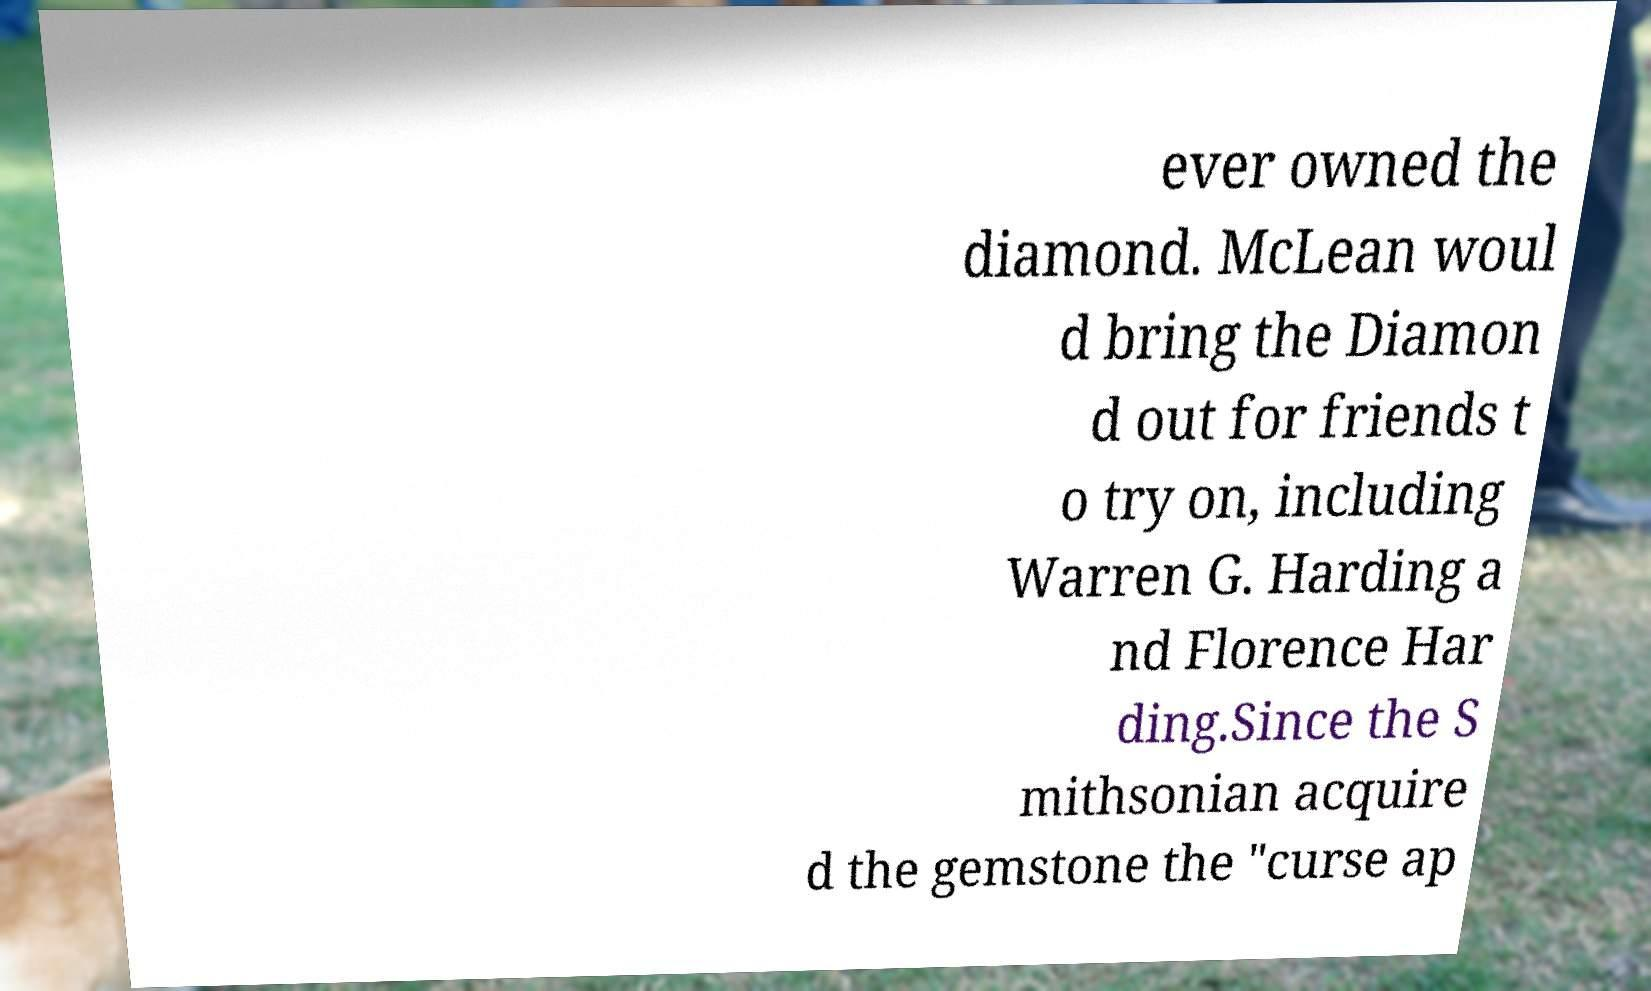Could you assist in decoding the text presented in this image and type it out clearly? ever owned the diamond. McLean woul d bring the Diamon d out for friends t o try on, including Warren G. Harding a nd Florence Har ding.Since the S mithsonian acquire d the gemstone the "curse ap 